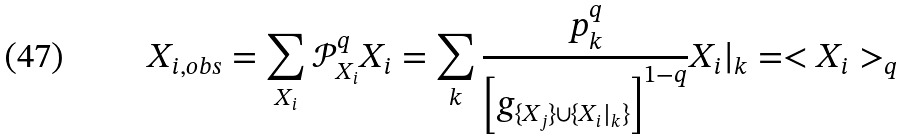<formula> <loc_0><loc_0><loc_500><loc_500>X _ { i , o b s } = \sum _ { X _ { i } } \mathcal { P } ^ { q } _ { X _ { i } } X _ { i } = \sum _ { k } \frac { p _ { k } ^ { q } } { \left [ g _ { \{ X _ { j } \} \cup \{ X _ { i } | _ { k } \} } \right ] ^ { 1 - q } } X _ { i } | _ { k } = < X _ { i } > _ { q }</formula> 